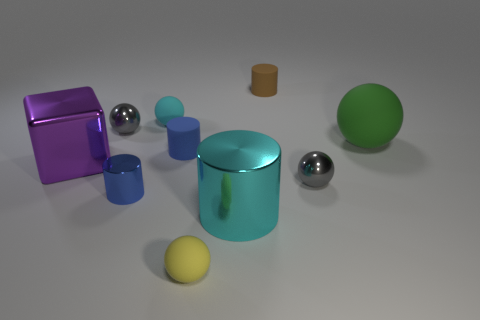Subtract 1 cylinders. How many cylinders are left? 3 Subtract all cyan spheres. How many spheres are left? 4 Subtract all yellow balls. How many balls are left? 4 Subtract all brown balls. Subtract all green blocks. How many balls are left? 5 Subtract all blocks. How many objects are left? 9 Add 2 rubber balls. How many rubber balls exist? 5 Subtract 0 green blocks. How many objects are left? 10 Subtract all blue cylinders. Subtract all large purple metal objects. How many objects are left? 7 Add 4 green spheres. How many green spheres are left? 5 